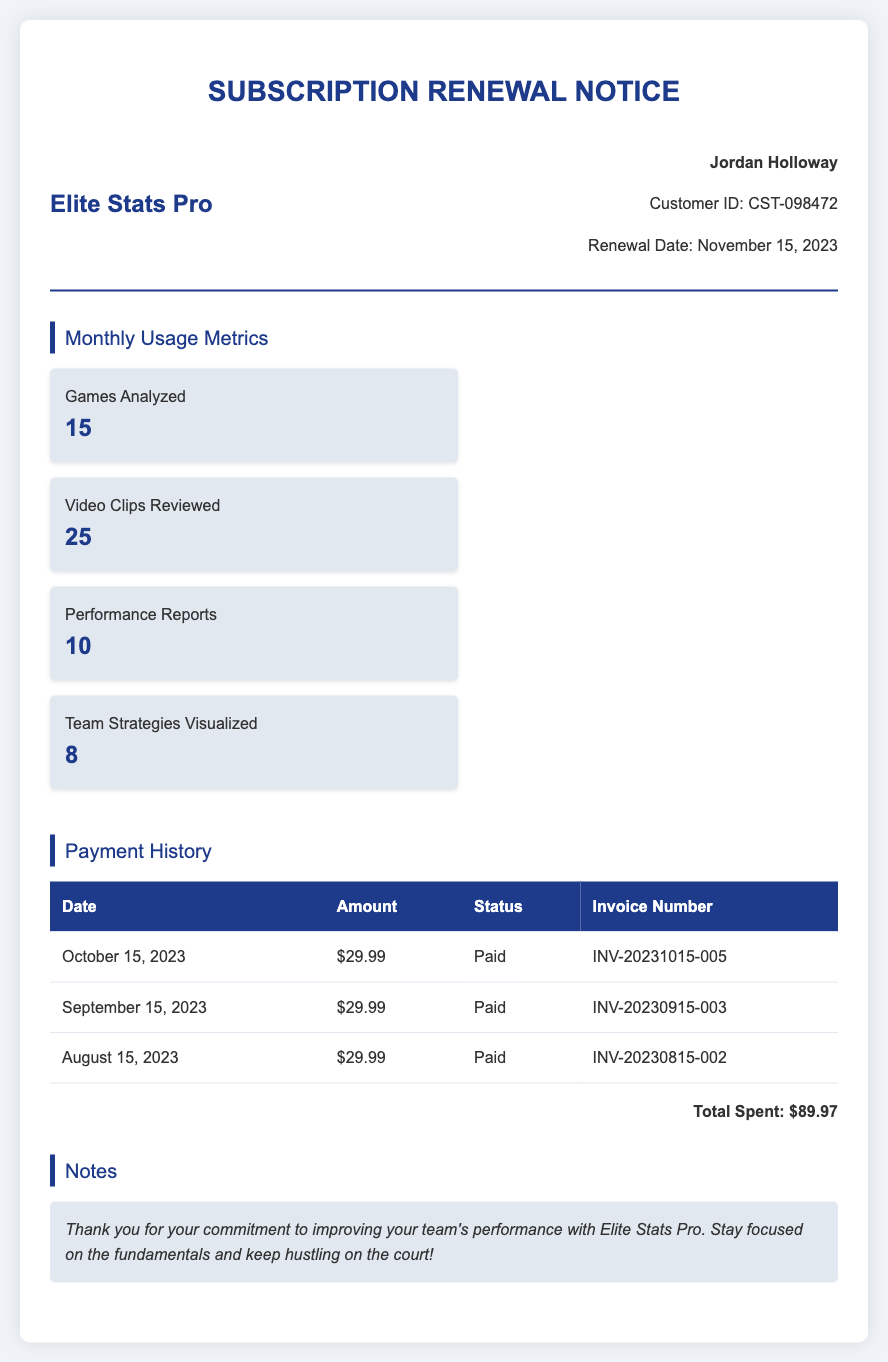What is the name of the customer? The customer's name is displayed prominently in the header section of the document.
Answer: Jordan Holloway What is the renewal date of the subscription? The renewal date is noted in the user information section of the document.
Answer: November 15, 2023 How many games were analyzed in the last month? The number of games analyzed is provided in the monthly usage metrics section.
Answer: 15 What is the total amount spent based on the payment history? The total spent is calculated from the payment history section, adding the amounts for each month listed.
Answer: $89.97 What was the status of the payment for October 2023? The payment status for October 2023 is clearly indicated in the payment history table.
Answer: Paid How many performance reports were generated last month? The number of performance reports is included in the monthly usage metrics section of the document.
Answer: 10 What invoice number corresponds to the payment made on September 15, 2023? The invoice number for the September payment can be found in the payment history table.
Answer: INV-20230915-003 What is the average payment amount based on the payment history? The average payment amount is determined by dividing the total spent by the number of payments made.
Answer: $29.99 What message is included in the notes section? The notes section contains a message thanking the customer and encouraging them to keep up the effort.
Answer: Thank you for your commitment to improving your team's performance with Elite Stats Pro. Stay focused on the fundamentals and keep hustling on the court! 